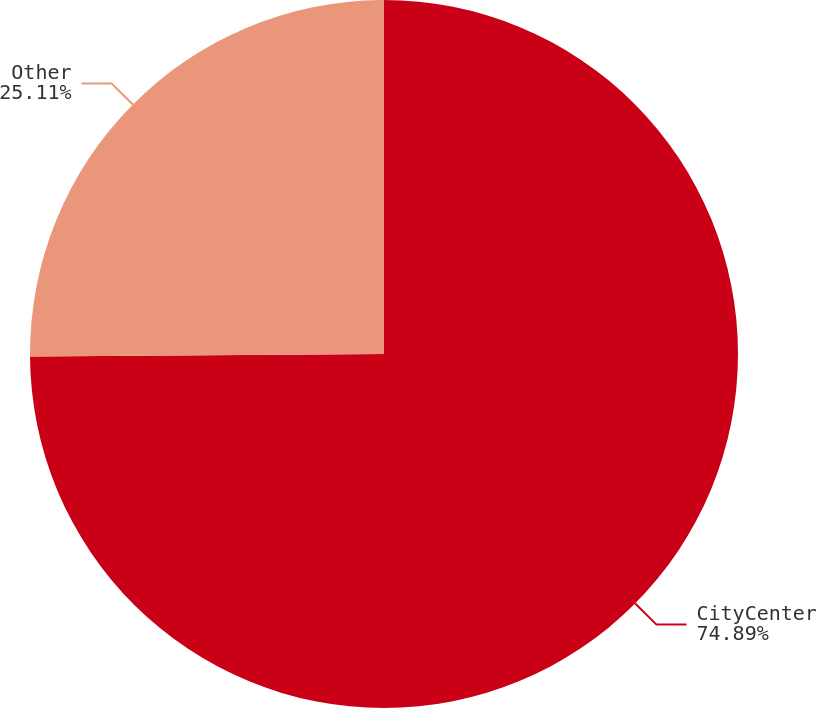Convert chart. <chart><loc_0><loc_0><loc_500><loc_500><pie_chart><fcel>CityCenter<fcel>Other<nl><fcel>74.89%<fcel>25.11%<nl></chart> 